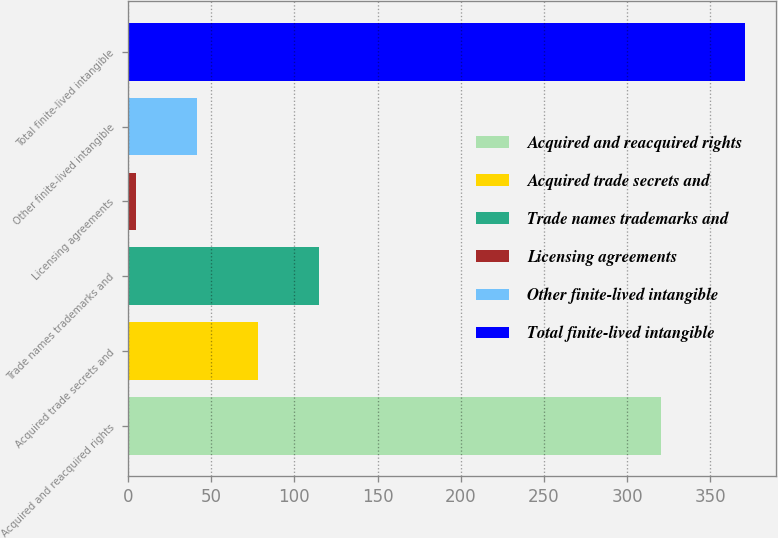<chart> <loc_0><loc_0><loc_500><loc_500><bar_chart><fcel>Acquired and reacquired rights<fcel>Acquired trade secrets and<fcel>Trade names trademarks and<fcel>Licensing agreements<fcel>Other finite-lived intangible<fcel>Total finite-lived intangible<nl><fcel>320.1<fcel>78.28<fcel>114.87<fcel>5.1<fcel>41.69<fcel>371<nl></chart> 